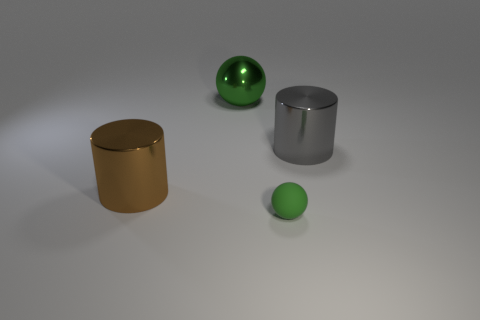What time of day does the lighting in the image suggest? The lighting in the image seems soft and diffused without any harsh shadows, which suggests an indoor setting with artificial lighting, such as studio lights, rather than natural light from a specific time of day. 